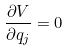<formula> <loc_0><loc_0><loc_500><loc_500>\frac { \partial V } { \partial q _ { j } } = 0</formula> 